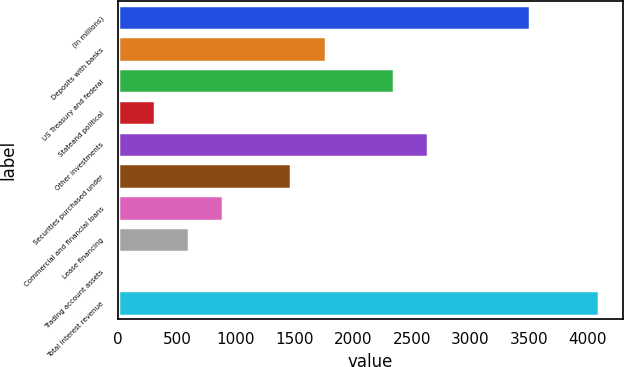Convert chart to OTSL. <chart><loc_0><loc_0><loc_500><loc_500><bar_chart><fcel>(In millions)<fcel>Deposits with banks<fcel>US Treasury and federal<fcel>Stateand political<fcel>Other investments<fcel>Securities purchased under<fcel>Commercial and financial loans<fcel>Lease financing<fcel>Trading account assets<fcel>Total interest revenue<nl><fcel>3511.8<fcel>1766.4<fcel>2348.2<fcel>311.9<fcel>2639.1<fcel>1475.5<fcel>893.7<fcel>602.8<fcel>21<fcel>4093.6<nl></chart> 